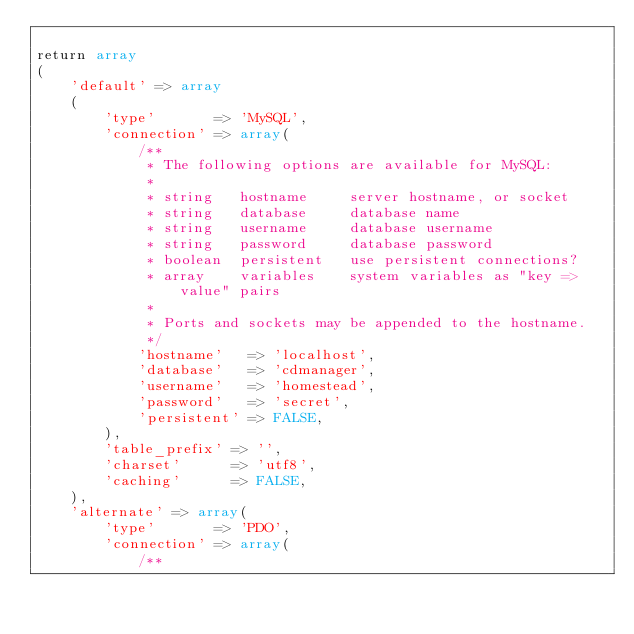<code> <loc_0><loc_0><loc_500><loc_500><_PHP_>
return array
(
	'default' => array
	(
		'type'       => 'MySQL',
		'connection' => array(
			/**
			 * The following options are available for MySQL:
			 *
			 * string   hostname     server hostname, or socket
			 * string   database     database name
			 * string   username     database username
			 * string   password     database password
			 * boolean  persistent   use persistent connections?
			 * array    variables    system variables as "key => value" pairs
			 *
			 * Ports and sockets may be appended to the hostname.
			 */
			'hostname'   => 'localhost',
			'database'   => 'cdmanager',
			'username'   => 'homestead',
			'password'   => 'secret',
			'persistent' => FALSE,
		),
		'table_prefix' => '',
		'charset'      => 'utf8',
		'caching'      => FALSE,
	),
	'alternate' => array(
		'type'       => 'PDO',
		'connection' => array(
			/**</code> 